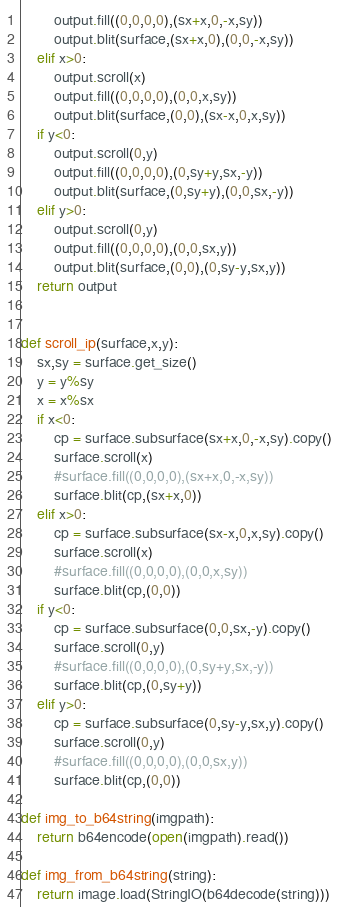Convert code to text. <code><loc_0><loc_0><loc_500><loc_500><_Python_>        output.fill((0,0,0,0),(sx+x,0,-x,sy))
        output.blit(surface,(sx+x,0),(0,0,-x,sy))
    elif x>0:
        output.scroll(x)
        output.fill((0,0,0,0),(0,0,x,sy))
        output.blit(surface,(0,0),(sx-x,0,x,sy))
    if y<0:
        output.scroll(0,y)
        output.fill((0,0,0,0),(0,sy+y,sx,-y))
        output.blit(surface,(0,sy+y),(0,0,sx,-y))
    elif y>0:
        output.scroll(0,y)
        output.fill((0,0,0,0),(0,0,sx,y))
        output.blit(surface,(0,0),(0,sy-y,sx,y))
    return output


def scroll_ip(surface,x,y):
    sx,sy = surface.get_size()
    y = y%sy
    x = x%sx
    if x<0:
        cp = surface.subsurface(sx+x,0,-x,sy).copy()
        surface.scroll(x)
        #surface.fill((0,0,0,0),(sx+x,0,-x,sy))
        surface.blit(cp,(sx+x,0))
    elif x>0:
        cp = surface.subsurface(sx-x,0,x,sy).copy()
        surface.scroll(x)
        #surface.fill((0,0,0,0),(0,0,x,sy))
        surface.blit(cp,(0,0))
    if y<0:
        cp = surface.subsurface(0,0,sx,-y).copy()
        surface.scroll(0,y)
        #surface.fill((0,0,0,0),(0,sy+y,sx,-y))
        surface.blit(cp,(0,sy+y))
    elif y>0:
        cp = surface.subsurface(0,sy-y,sx,y).copy()
        surface.scroll(0,y)
        #surface.fill((0,0,0,0),(0,0,sx,y))
        surface.blit(cp,(0,0))

def img_to_b64string(imgpath):
    return b64encode(open(imgpath).read())

def img_from_b64string(string):
    return image.load(StringIO(b64decode(string)))
</code> 